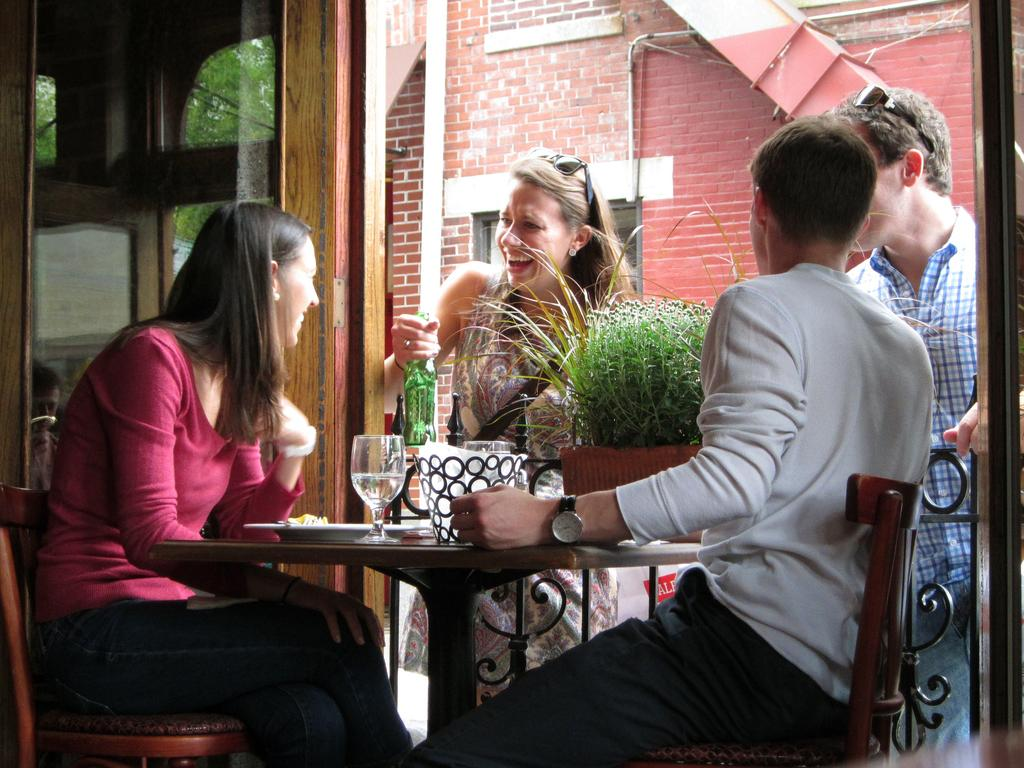What are the people in the image doing? There are people sitting on chairs and standing in the image. What furniture is present in the image? There is a table in the image. What is on the table? There is a wine glass on the table. What type of poison is being served in the wine glass in the image? There is no poison present in the image; it is a wine glass, and no liquid is visible inside it. Who is the writer in the image? There is no writer present in the image. 